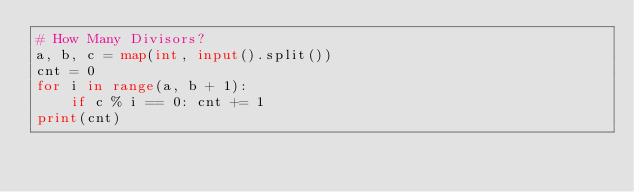<code> <loc_0><loc_0><loc_500><loc_500><_Python_># How Many Divisors?
a, b, c = map(int, input().split())
cnt = 0
for i in range(a, b + 1):
    if c % i == 0: cnt += 1
print(cnt)
</code> 